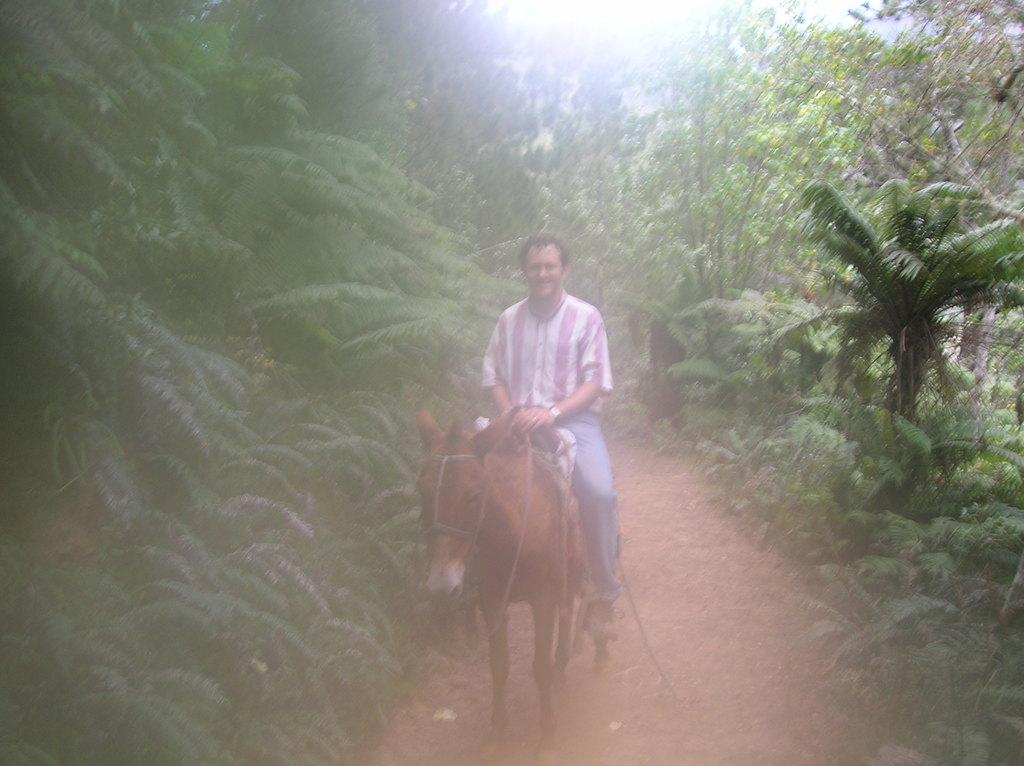Who is present in the image? There is a man in the image. What is the man doing in the image? The man is sitting on a horse. What can be seen in the background of the image? There are trees visible in the background of the image. What type of calculator is the man holding while riding the horse? There is no calculator present in the image; the man is simply sitting on a horse. 